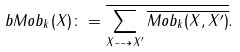Convert formula to latex. <formula><loc_0><loc_0><loc_500><loc_500>b M o b _ { k } ( X ) \colon = \overline { \sum _ { X \dashrightarrow X ^ { \prime } } \overline { M o b _ { k } ( X , X ^ { \prime } ) } } .</formula> 